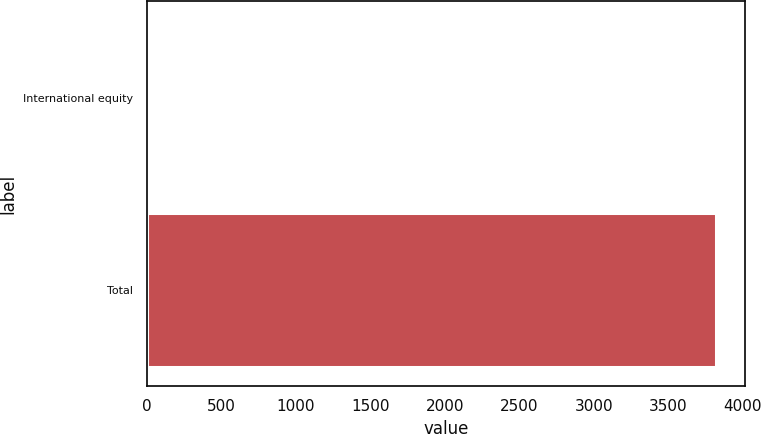Convert chart. <chart><loc_0><loc_0><loc_500><loc_500><bar_chart><fcel>International equity<fcel>Total<nl><fcel>7<fcel>3823<nl></chart> 